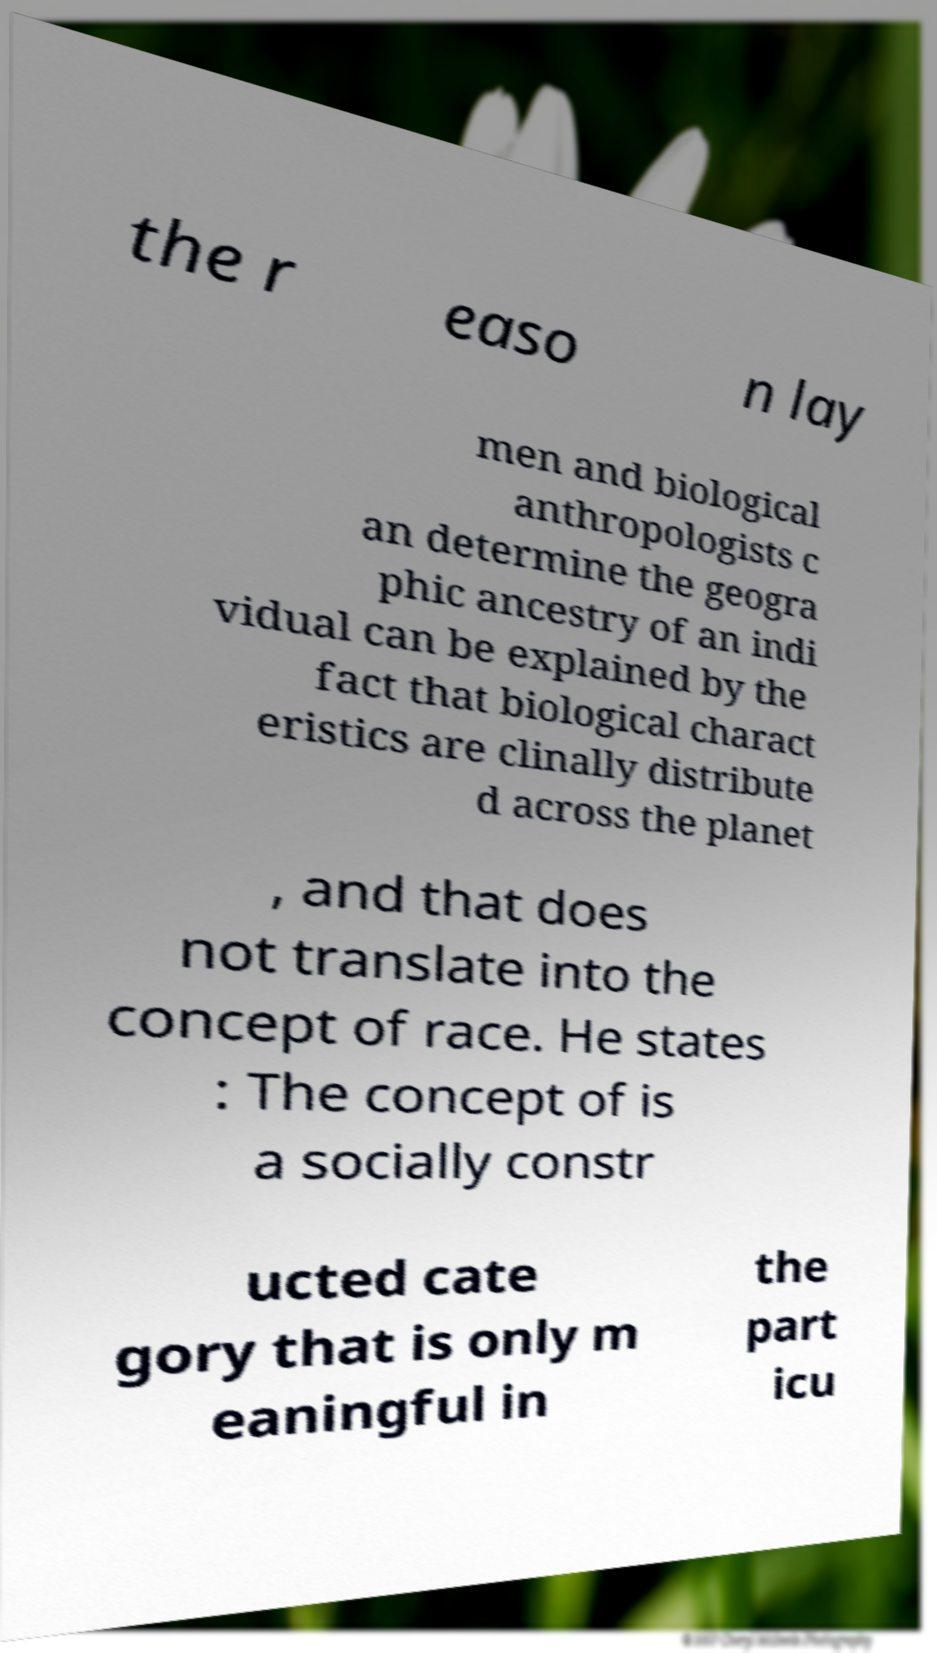Could you assist in decoding the text presented in this image and type it out clearly? the r easo n lay men and biological anthropologists c an determine the geogra phic ancestry of an indi vidual can be explained by the fact that biological charact eristics are clinally distribute d across the planet , and that does not translate into the concept of race. He states : The concept of is a socially constr ucted cate gory that is only m eaningful in the part icu 